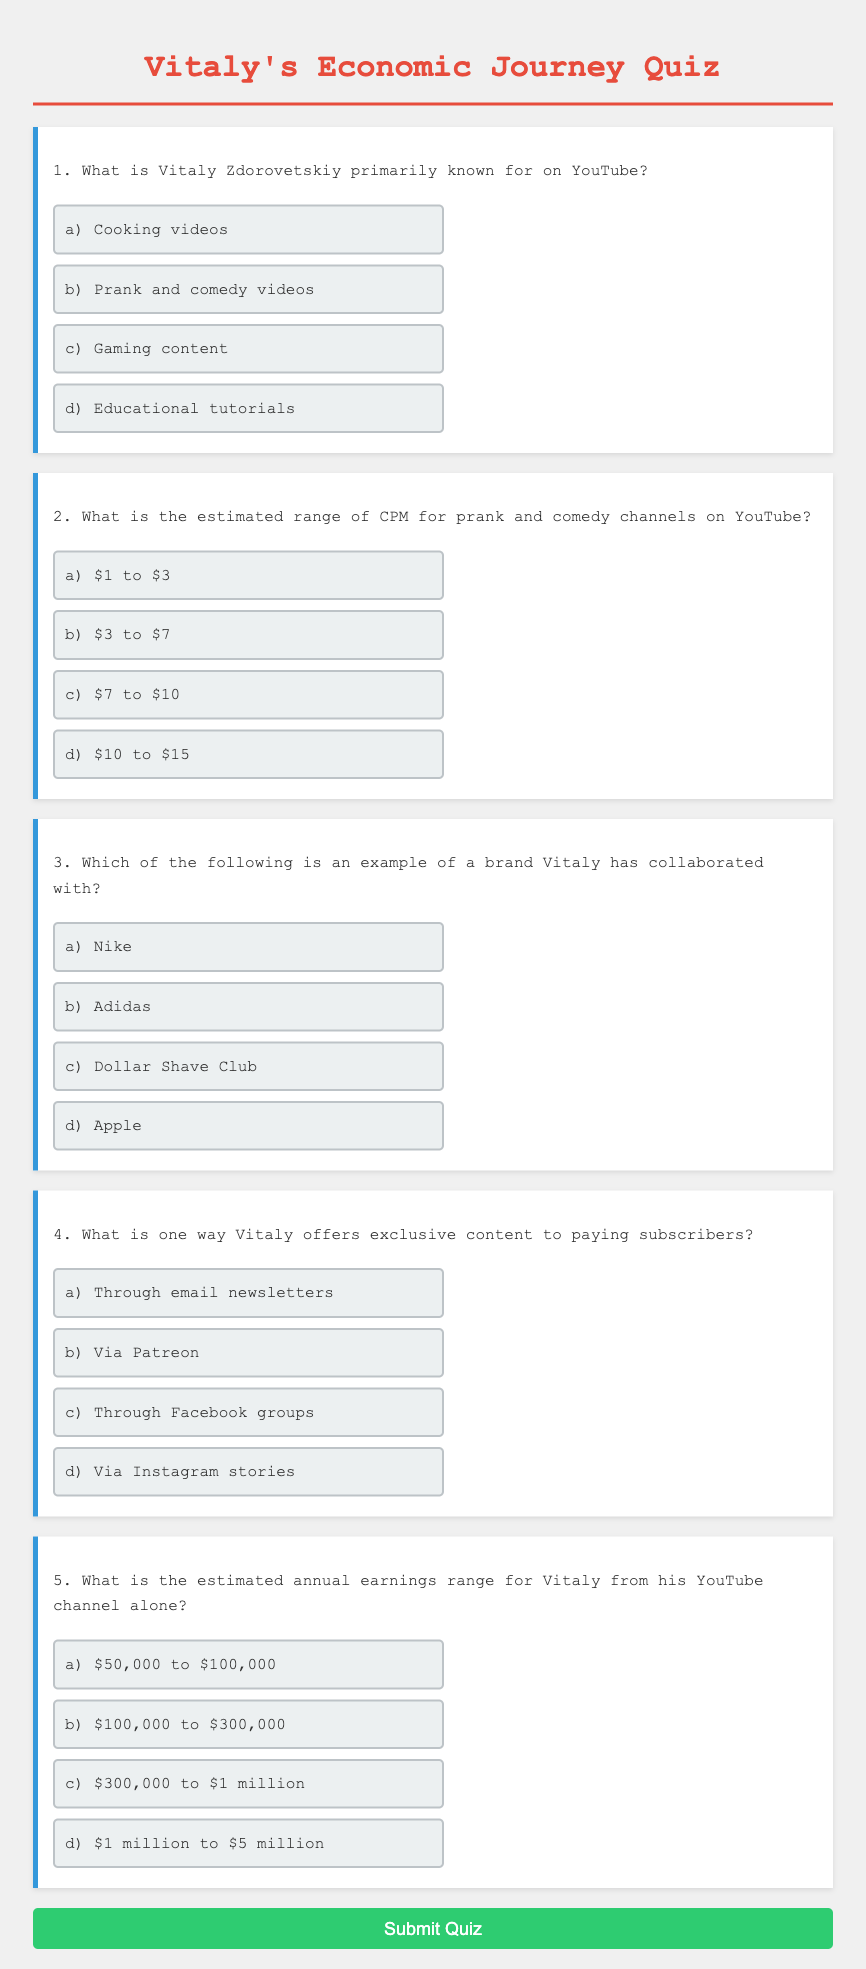What is Vitaly Zdorovetskiy primarily known for on YouTube? The document states that Vitaly is primarily known for prank and comedy videos, which is mentioned in the first question.
Answer: prank and comedy videos What is the estimated range of CPM for prank and comedy channels on YouTube? The second question in the document highlights the estimated CPM range specifically for prank and comedy channels.
Answer: $3 to $7 Which brand has Vitaly collaborated with? The document provides an example of a brand Vitaly has worked with, specifically mentioned in the third question.
Answer: Dollar Shave Club How does Vitaly offer exclusive content to paying subscribers? The fourth question indicates that Vitaly provides exclusive content via a specific platform, which is mentioned in the document.
Answer: Via Patreon What is the estimated annual earnings range for Vitaly from his YouTube channel alone? The fifth question addresses the estimated annual earnings specifically from his YouTube channel.
Answer: $100,000 to $300,000 